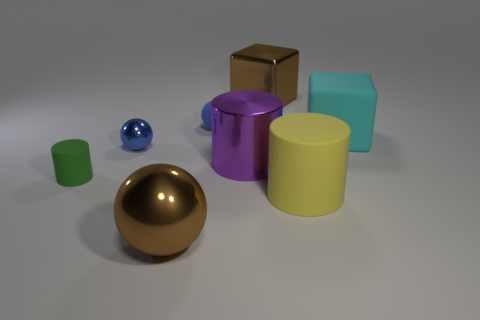Subtract 1 balls. How many balls are left? 2 Add 2 small brown shiny cubes. How many objects exist? 10 Subtract all cubes. How many objects are left? 6 Add 6 large green cylinders. How many large green cylinders exist? 6 Subtract 0 gray spheres. How many objects are left? 8 Subtract all big cylinders. Subtract all brown metal blocks. How many objects are left? 5 Add 3 big brown cubes. How many big brown cubes are left? 4 